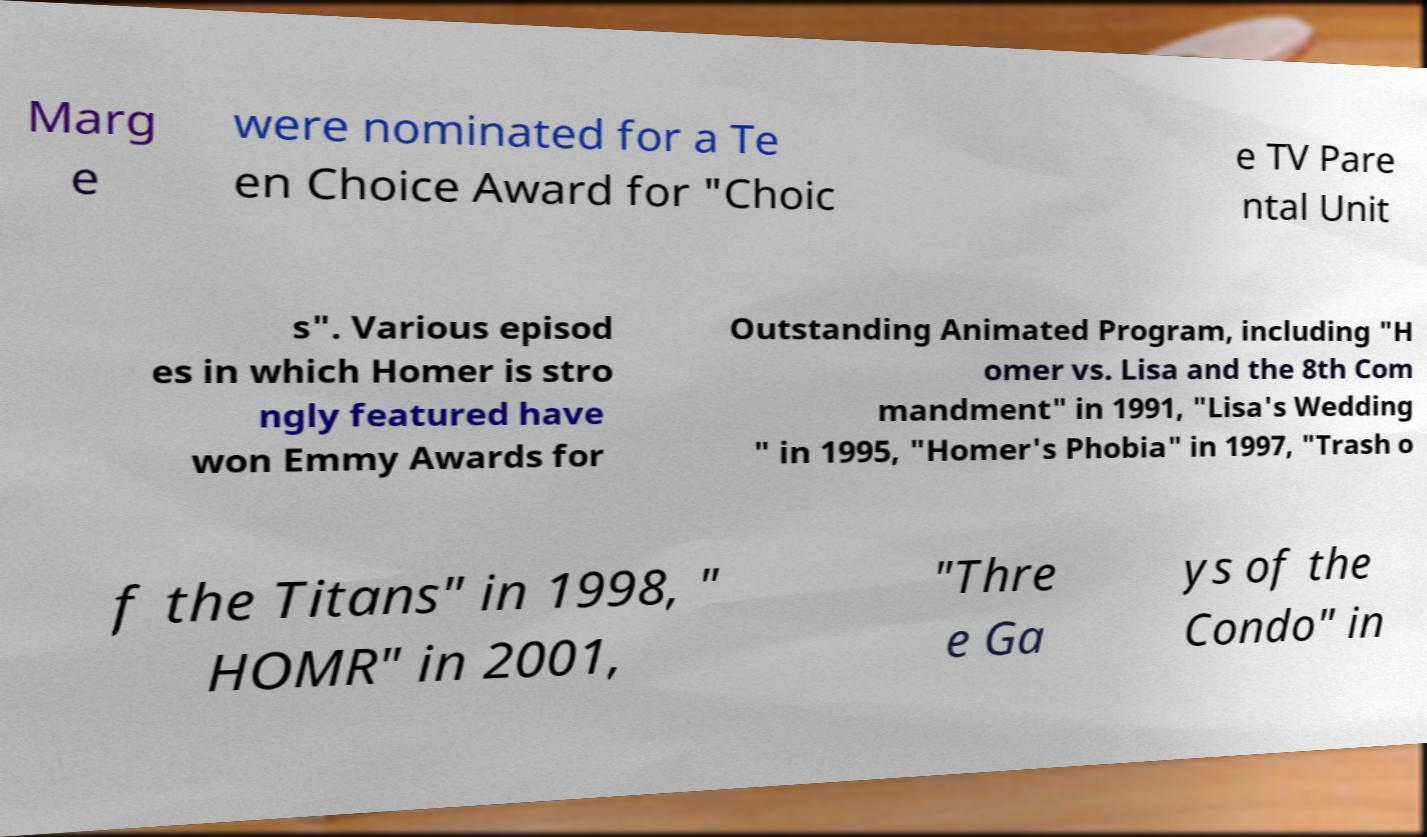There's text embedded in this image that I need extracted. Can you transcribe it verbatim? Marg e were nominated for a Te en Choice Award for "Choic e TV Pare ntal Unit s". Various episod es in which Homer is stro ngly featured have won Emmy Awards for Outstanding Animated Program, including "H omer vs. Lisa and the 8th Com mandment" in 1991, "Lisa's Wedding " in 1995, "Homer's Phobia" in 1997, "Trash o f the Titans" in 1998, " HOMR" in 2001, "Thre e Ga ys of the Condo" in 